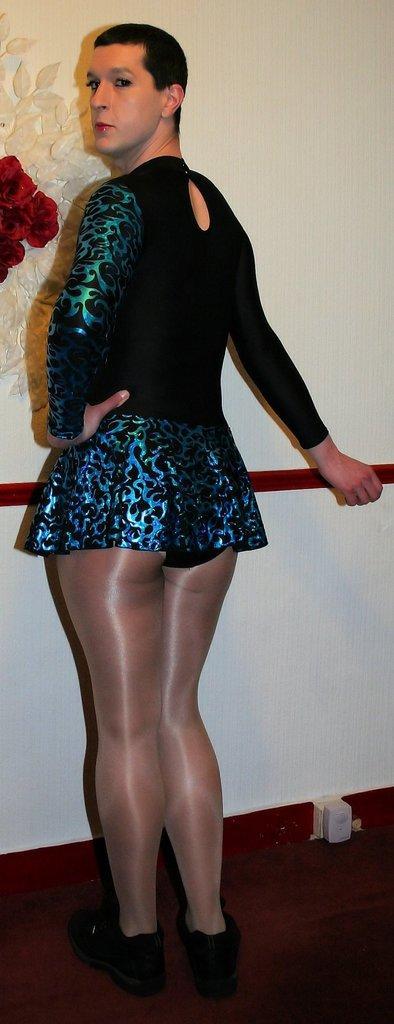How would you summarize this image in a sentence or two? In this image I can see the person with the black, green and blue color dress. To the left I can see red color flowers and there is wall in the back. 